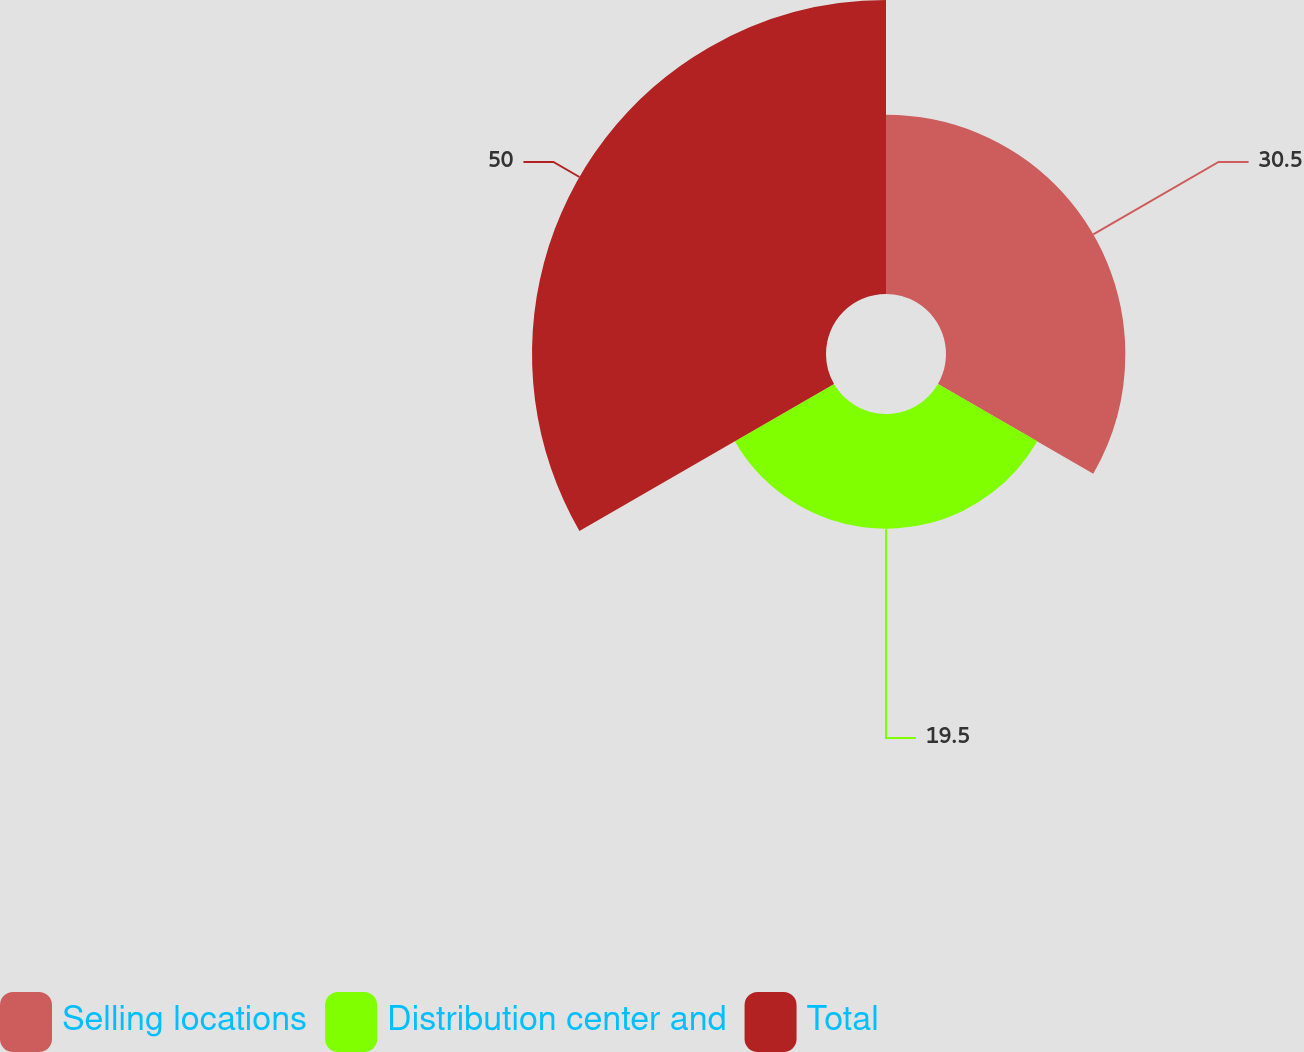Convert chart. <chart><loc_0><loc_0><loc_500><loc_500><pie_chart><fcel>Selling locations<fcel>Distribution center and<fcel>Total<nl><fcel>30.5%<fcel>19.5%<fcel>50.0%<nl></chart> 